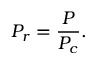Convert formula to latex. <formula><loc_0><loc_0><loc_500><loc_500>P _ { r } = { \frac { P } { P _ { c } } } .</formula> 